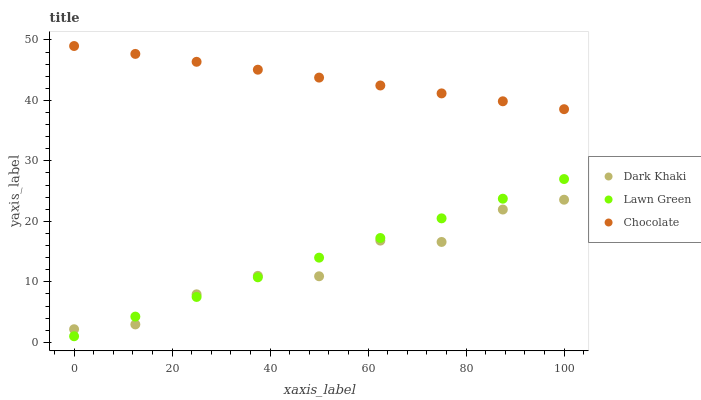Does Dark Khaki have the minimum area under the curve?
Answer yes or no. Yes. Does Chocolate have the maximum area under the curve?
Answer yes or no. Yes. Does Lawn Green have the minimum area under the curve?
Answer yes or no. No. Does Lawn Green have the maximum area under the curve?
Answer yes or no. No. Is Lawn Green the smoothest?
Answer yes or no. Yes. Is Dark Khaki the roughest?
Answer yes or no. Yes. Is Chocolate the smoothest?
Answer yes or no. No. Is Chocolate the roughest?
Answer yes or no. No. Does Lawn Green have the lowest value?
Answer yes or no. Yes. Does Chocolate have the lowest value?
Answer yes or no. No. Does Chocolate have the highest value?
Answer yes or no. Yes. Does Lawn Green have the highest value?
Answer yes or no. No. Is Lawn Green less than Chocolate?
Answer yes or no. Yes. Is Chocolate greater than Lawn Green?
Answer yes or no. Yes. Does Dark Khaki intersect Lawn Green?
Answer yes or no. Yes. Is Dark Khaki less than Lawn Green?
Answer yes or no. No. Is Dark Khaki greater than Lawn Green?
Answer yes or no. No. Does Lawn Green intersect Chocolate?
Answer yes or no. No. 